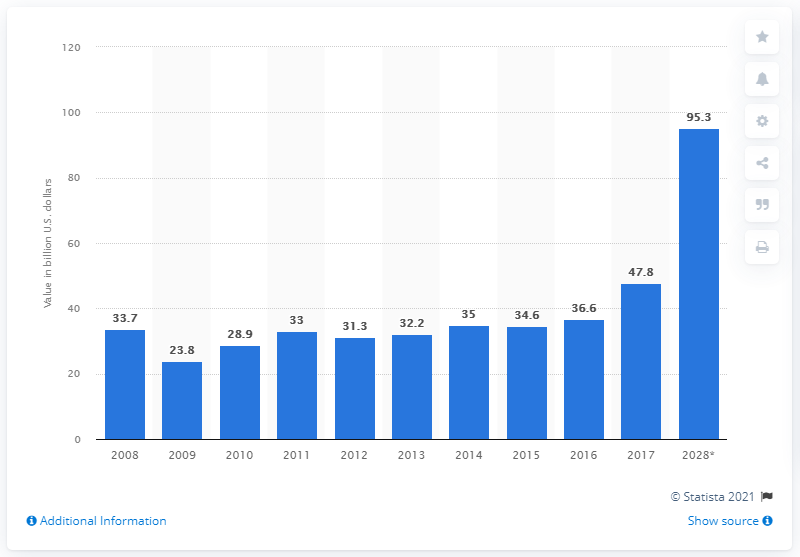Give some essential details in this illustration. In 2008, there was a significant increase in capital investments in the tourism sector. In 2017, the value of capital investments in the tourism sector was 47.8 billion US dollars. The forecast value of capital investments in the tourism sector in 2028 was $95.3 million. 